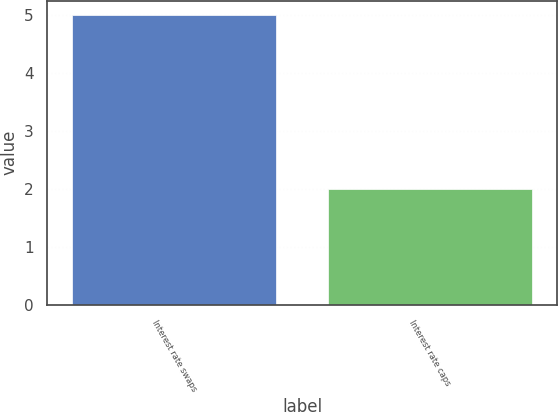<chart> <loc_0><loc_0><loc_500><loc_500><bar_chart><fcel>Interest rate swaps<fcel>Interest rate caps<nl><fcel>5<fcel>2<nl></chart> 